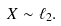Convert formula to latex. <formula><loc_0><loc_0><loc_500><loc_500>X \sim \ell _ { 2 } .</formula> 